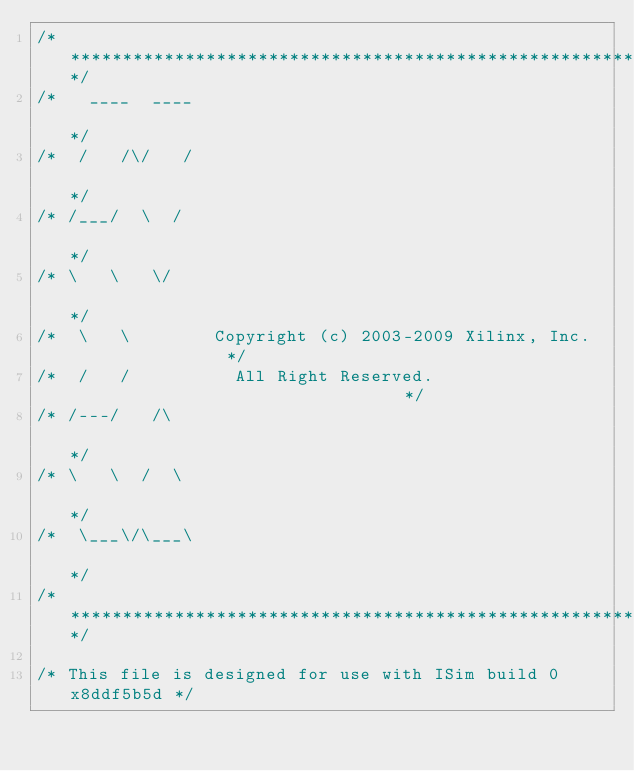<code> <loc_0><loc_0><loc_500><loc_500><_C_>/**********************************************************************/
/*   ____  ____                                                       */
/*  /   /\/   /                                                       */
/* /___/  \  /                                                        */
/* \   \   \/                                                       */
/*  \   \        Copyright (c) 2003-2009 Xilinx, Inc.                */
/*  /   /          All Right Reserved.                                 */
/* /---/   /\                                                         */
/* \   \  /  \                                                      */
/*  \___\/\___\                                                    */
/***********************************************************************/

/* This file is designed for use with ISim build 0x8ddf5b5d */
</code> 